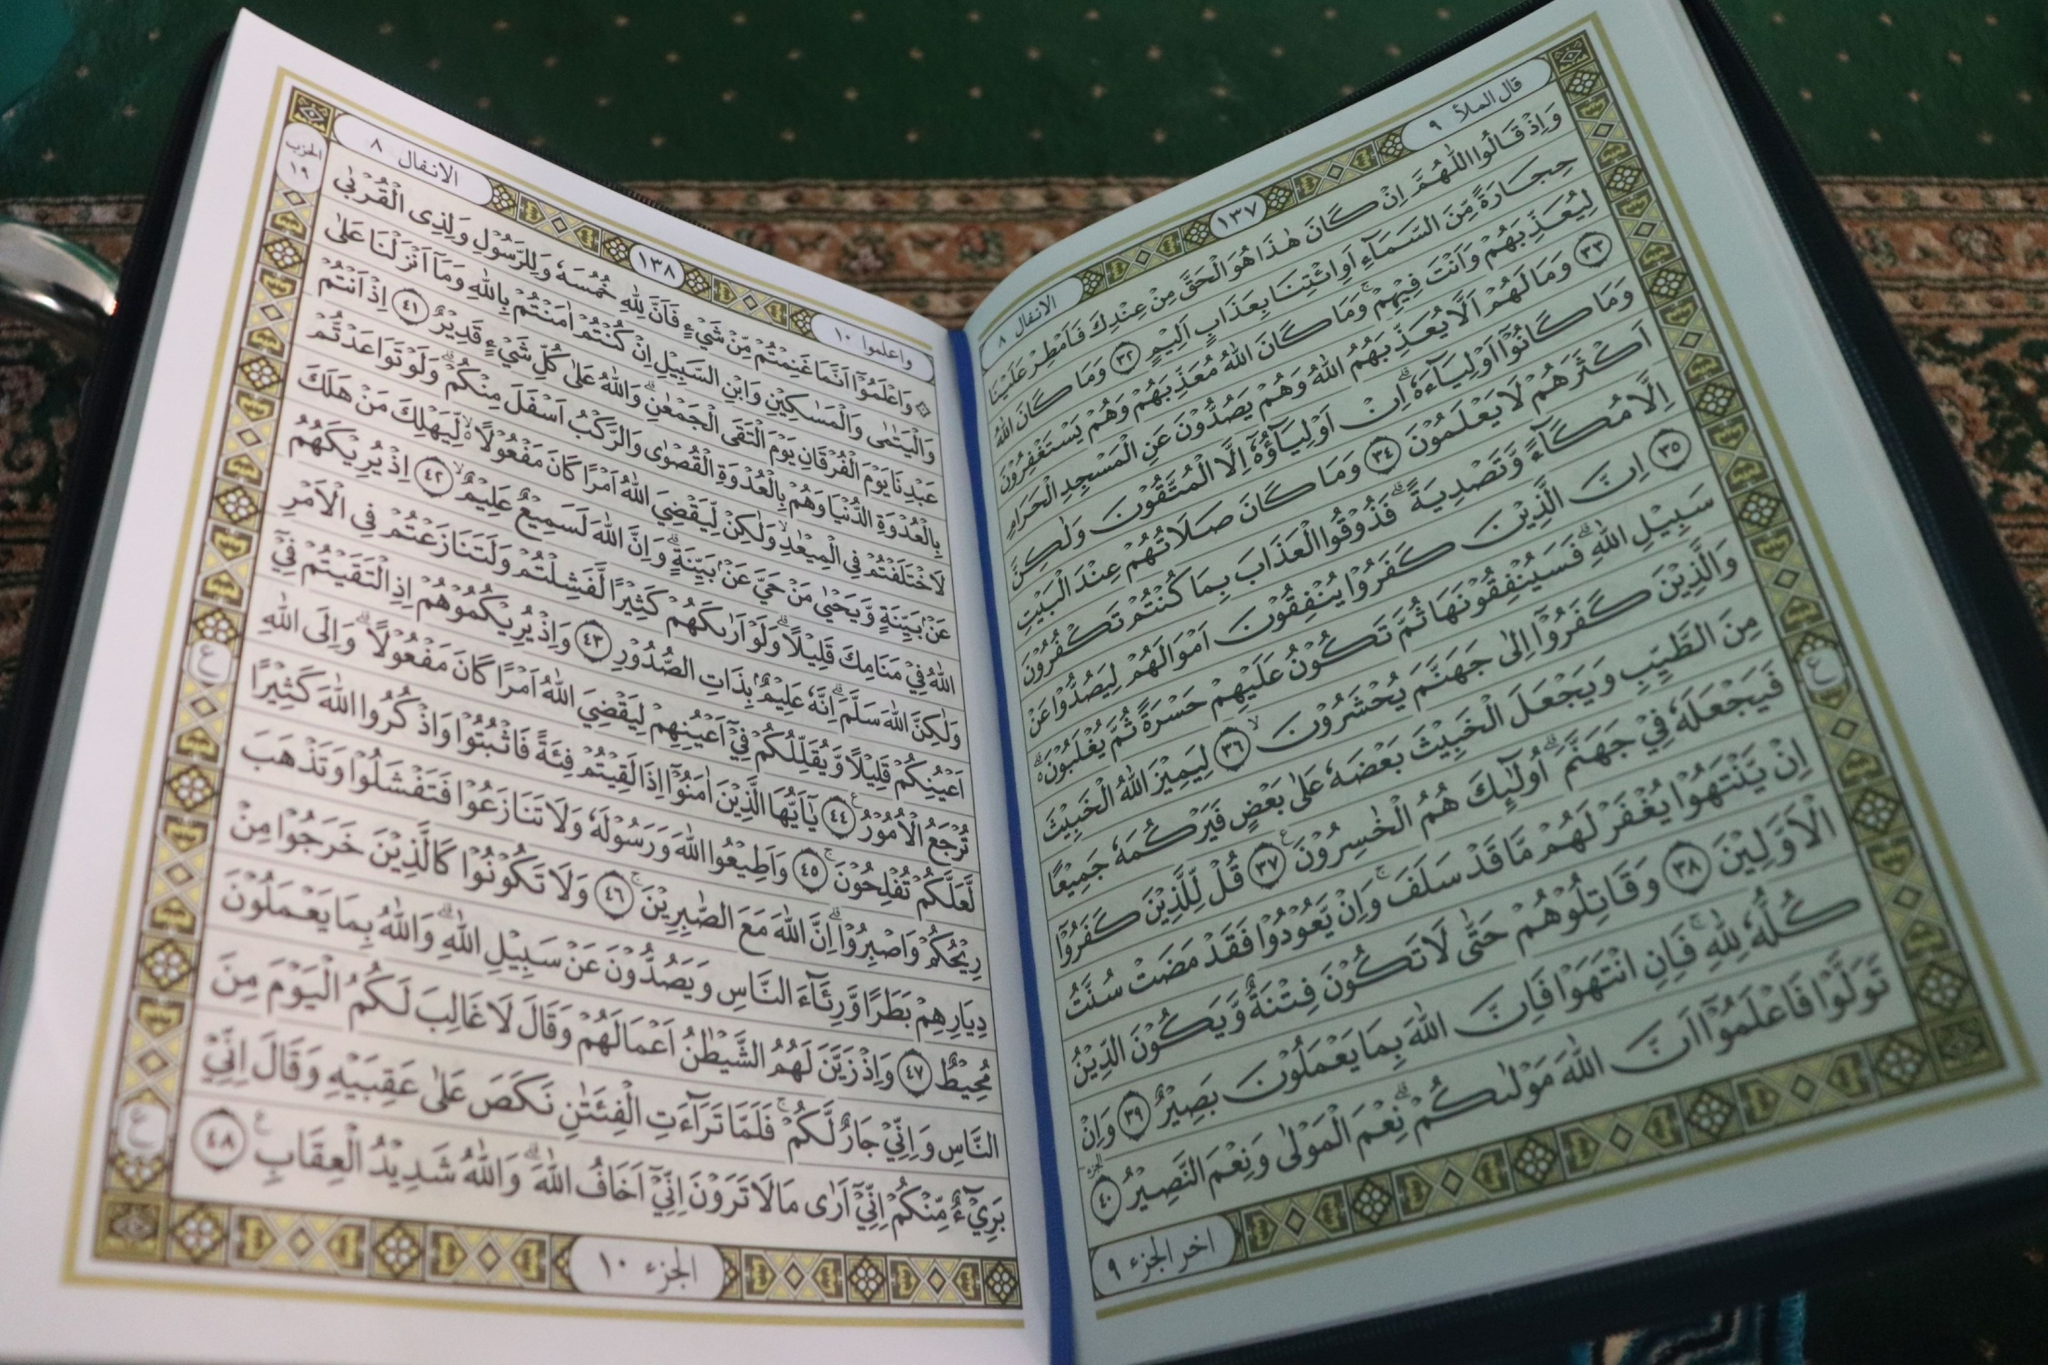Transport us to a day in the life of a scribe who might have worked on this book. In a tranquil scriptorium bathed in soft sunlight filtering through ornate windows, the scribe, dressed in simple yet elegant robes, sits at a finely crafted wooden desk. The air is filled with the faint scent of ink and parchment. The scribe meticulously dips his quill into an inkpot of rich, dark ink, beginning his day by penning a prayer for patience and precision. Each stroke is deliberate, a blend of artistic grace and unwavering devotion. Hours pass as he transcribes the sacred text, occasionally pausing to adjust the intricate gold-leafed patterns that border each page. His workspace is silent but for the gentle scratching of the quill, a serene environment designed to foster contemplation and reverence. As the sun sets, casting a warm golden glow across the room, he reflects on the spiritual significance of his work, feeling a deep connection to the divine truths he helps to perpetuate through his careful craftsmanship. 